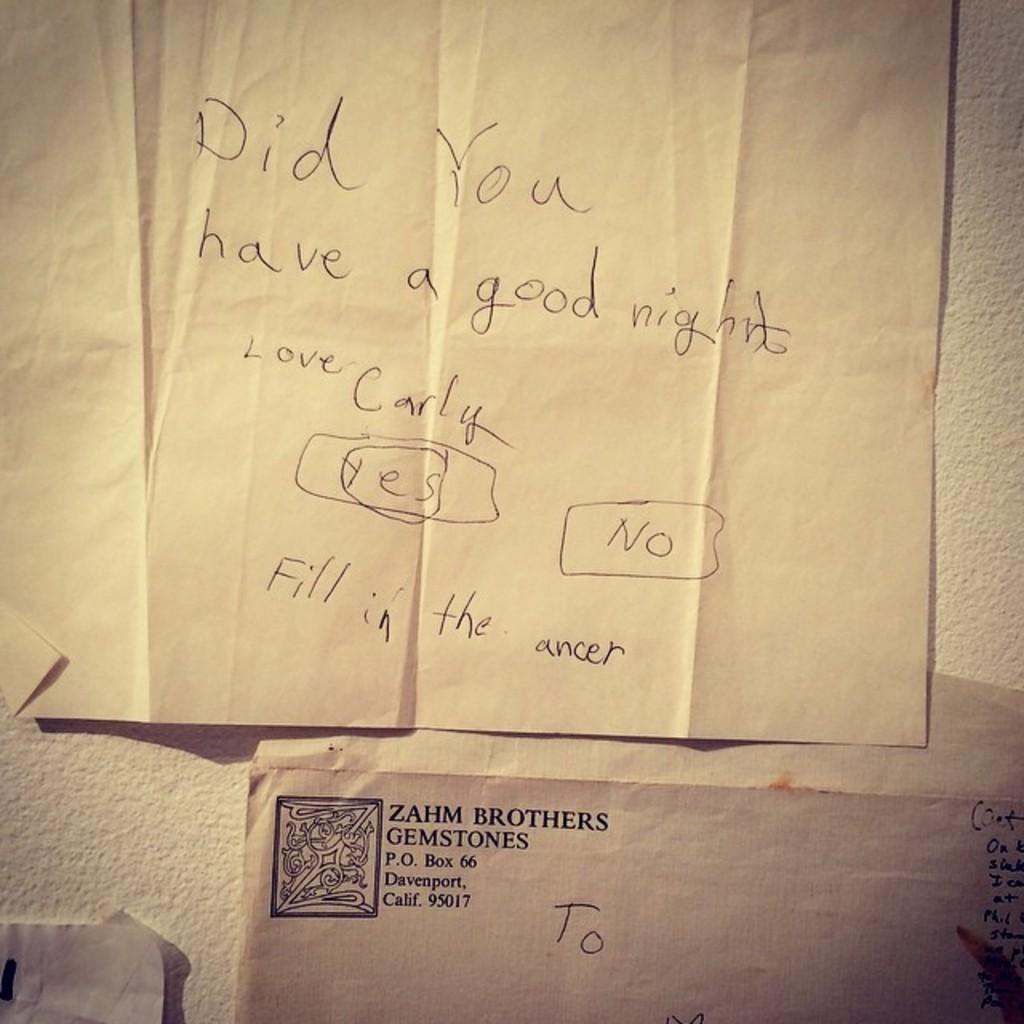What does the paper say on the first word?
Your answer should be very brief. Did. Did carly have a good night?
Offer a very short reply. Yes. 